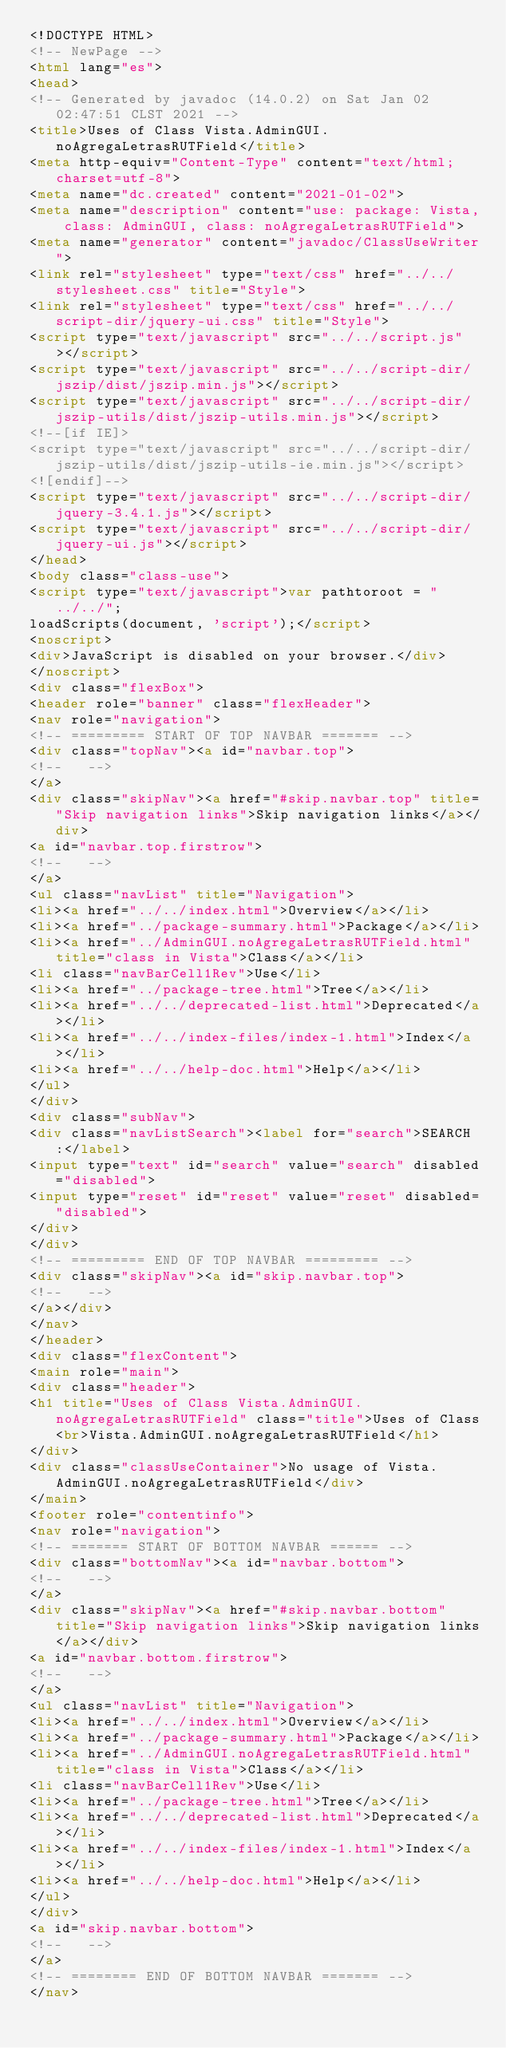Convert code to text. <code><loc_0><loc_0><loc_500><loc_500><_HTML_><!DOCTYPE HTML>
<!-- NewPage -->
<html lang="es">
<head>
<!-- Generated by javadoc (14.0.2) on Sat Jan 02 02:47:51 CLST 2021 -->
<title>Uses of Class Vista.AdminGUI.noAgregaLetrasRUTField</title>
<meta http-equiv="Content-Type" content="text/html; charset=utf-8">
<meta name="dc.created" content="2021-01-02">
<meta name="description" content="use: package: Vista, class: AdminGUI, class: noAgregaLetrasRUTField">
<meta name="generator" content="javadoc/ClassUseWriter">
<link rel="stylesheet" type="text/css" href="../../stylesheet.css" title="Style">
<link rel="stylesheet" type="text/css" href="../../script-dir/jquery-ui.css" title="Style">
<script type="text/javascript" src="../../script.js"></script>
<script type="text/javascript" src="../../script-dir/jszip/dist/jszip.min.js"></script>
<script type="text/javascript" src="../../script-dir/jszip-utils/dist/jszip-utils.min.js"></script>
<!--[if IE]>
<script type="text/javascript" src="../../script-dir/jszip-utils/dist/jszip-utils-ie.min.js"></script>
<![endif]-->
<script type="text/javascript" src="../../script-dir/jquery-3.4.1.js"></script>
<script type="text/javascript" src="../../script-dir/jquery-ui.js"></script>
</head>
<body class="class-use">
<script type="text/javascript">var pathtoroot = "../../";
loadScripts(document, 'script');</script>
<noscript>
<div>JavaScript is disabled on your browser.</div>
</noscript>
<div class="flexBox">
<header role="banner" class="flexHeader">
<nav role="navigation">
<!-- ========= START OF TOP NAVBAR ======= -->
<div class="topNav"><a id="navbar.top">
<!--   -->
</a>
<div class="skipNav"><a href="#skip.navbar.top" title="Skip navigation links">Skip navigation links</a></div>
<a id="navbar.top.firstrow">
<!--   -->
</a>
<ul class="navList" title="Navigation">
<li><a href="../../index.html">Overview</a></li>
<li><a href="../package-summary.html">Package</a></li>
<li><a href="../AdminGUI.noAgregaLetrasRUTField.html" title="class in Vista">Class</a></li>
<li class="navBarCell1Rev">Use</li>
<li><a href="../package-tree.html">Tree</a></li>
<li><a href="../../deprecated-list.html">Deprecated</a></li>
<li><a href="../../index-files/index-1.html">Index</a></li>
<li><a href="../../help-doc.html">Help</a></li>
</ul>
</div>
<div class="subNav">
<div class="navListSearch"><label for="search">SEARCH:</label>
<input type="text" id="search" value="search" disabled="disabled">
<input type="reset" id="reset" value="reset" disabled="disabled">
</div>
</div>
<!-- ========= END OF TOP NAVBAR ========= -->
<div class="skipNav"><a id="skip.navbar.top">
<!--   -->
</a></div>
</nav>
</header>
<div class="flexContent">
<main role="main">
<div class="header">
<h1 title="Uses of Class Vista.AdminGUI.noAgregaLetrasRUTField" class="title">Uses of Class<br>Vista.AdminGUI.noAgregaLetrasRUTField</h1>
</div>
<div class="classUseContainer">No usage of Vista.AdminGUI.noAgregaLetrasRUTField</div>
</main>
<footer role="contentinfo">
<nav role="navigation">
<!-- ======= START OF BOTTOM NAVBAR ====== -->
<div class="bottomNav"><a id="navbar.bottom">
<!--   -->
</a>
<div class="skipNav"><a href="#skip.navbar.bottom" title="Skip navigation links">Skip navigation links</a></div>
<a id="navbar.bottom.firstrow">
<!--   -->
</a>
<ul class="navList" title="Navigation">
<li><a href="../../index.html">Overview</a></li>
<li><a href="../package-summary.html">Package</a></li>
<li><a href="../AdminGUI.noAgregaLetrasRUTField.html" title="class in Vista">Class</a></li>
<li class="navBarCell1Rev">Use</li>
<li><a href="../package-tree.html">Tree</a></li>
<li><a href="../../deprecated-list.html">Deprecated</a></li>
<li><a href="../../index-files/index-1.html">Index</a></li>
<li><a href="../../help-doc.html">Help</a></li>
</ul>
</div>
<a id="skip.navbar.bottom">
<!--   -->
</a>
<!-- ======== END OF BOTTOM NAVBAR ======= -->
</nav></code> 